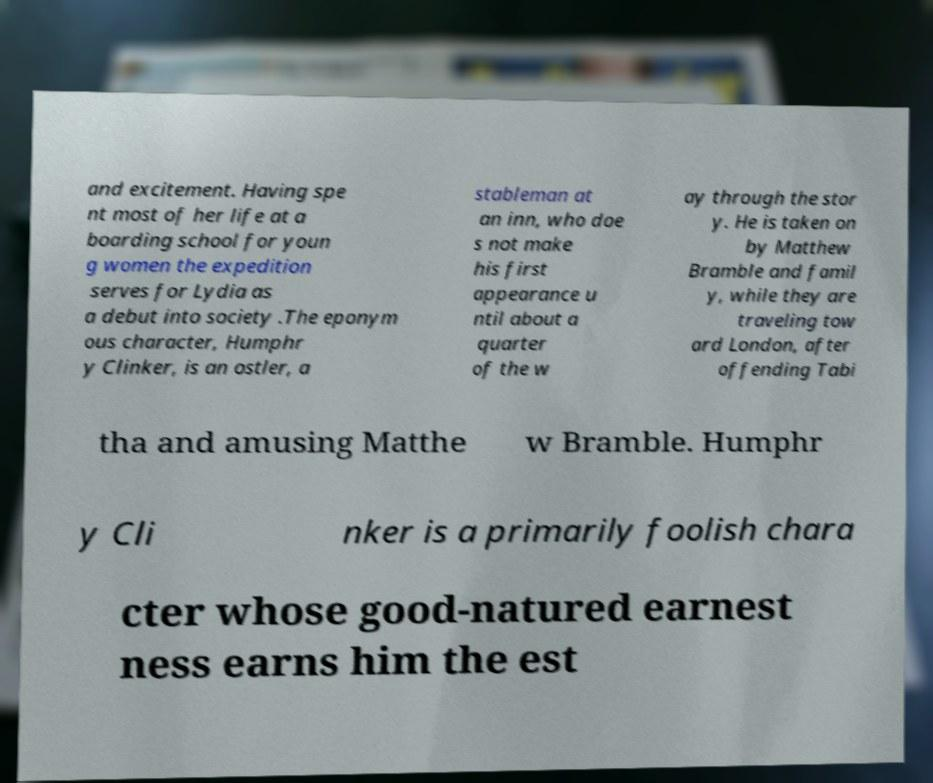What messages or text are displayed in this image? I need them in a readable, typed format. and excitement. Having spe nt most of her life at a boarding school for youn g women the expedition serves for Lydia as a debut into society .The eponym ous character, Humphr y Clinker, is an ostler, a stableman at an inn, who doe s not make his first appearance u ntil about a quarter of the w ay through the stor y. He is taken on by Matthew Bramble and famil y, while they are traveling tow ard London, after offending Tabi tha and amusing Matthe w Bramble. Humphr y Cli nker is a primarily foolish chara cter whose good-natured earnest ness earns him the est 